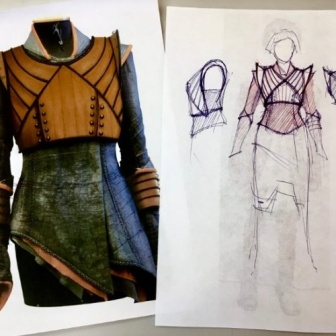Analyze the image in a comprehensive and detailed manner. In the image, there are two main elements: a finished garment and its corresponding design sketch, both displayed against a white background. The garment, which is mounted on a white dress form, is a dress of brown and green hues. It features a high collar and a layered skirt, adding depth and texture to the piece. 

Adjacent to the dress, the design sketch is presented on a white piece of paper. It's a black and white line drawing that mirrors the dress's design, complete with details and notes that likely guided the creation of the finished garment. The sketch and the dress form are positioned side by side, creating a visual comparison between the initial design and the final product. 

The image captures the transformation from concept to reality in the world of fashion design, providing a glimpse into the creative process behind the creation of a dress. The absence of any text or other objects in the image allows the viewer to focus solely on the dress and its sketch, emphasizing the importance of these two elements in the image. 

The image does not contain any discernible actions, as it appears to be a static display of a dress and its design sketch. The precise locations of the objects are not specified beyond their placement side by side against a white wall. There are no texts visible in the image. The relative positions of the objects suggest a deliberate arrangement for comparison or display purposes. 

This detailed description is based on the visible content of the image and does not include any speculative or imaginary content. The description aims to provide a comprehensive understanding of the image while minimizing aesthetic interpretations. 